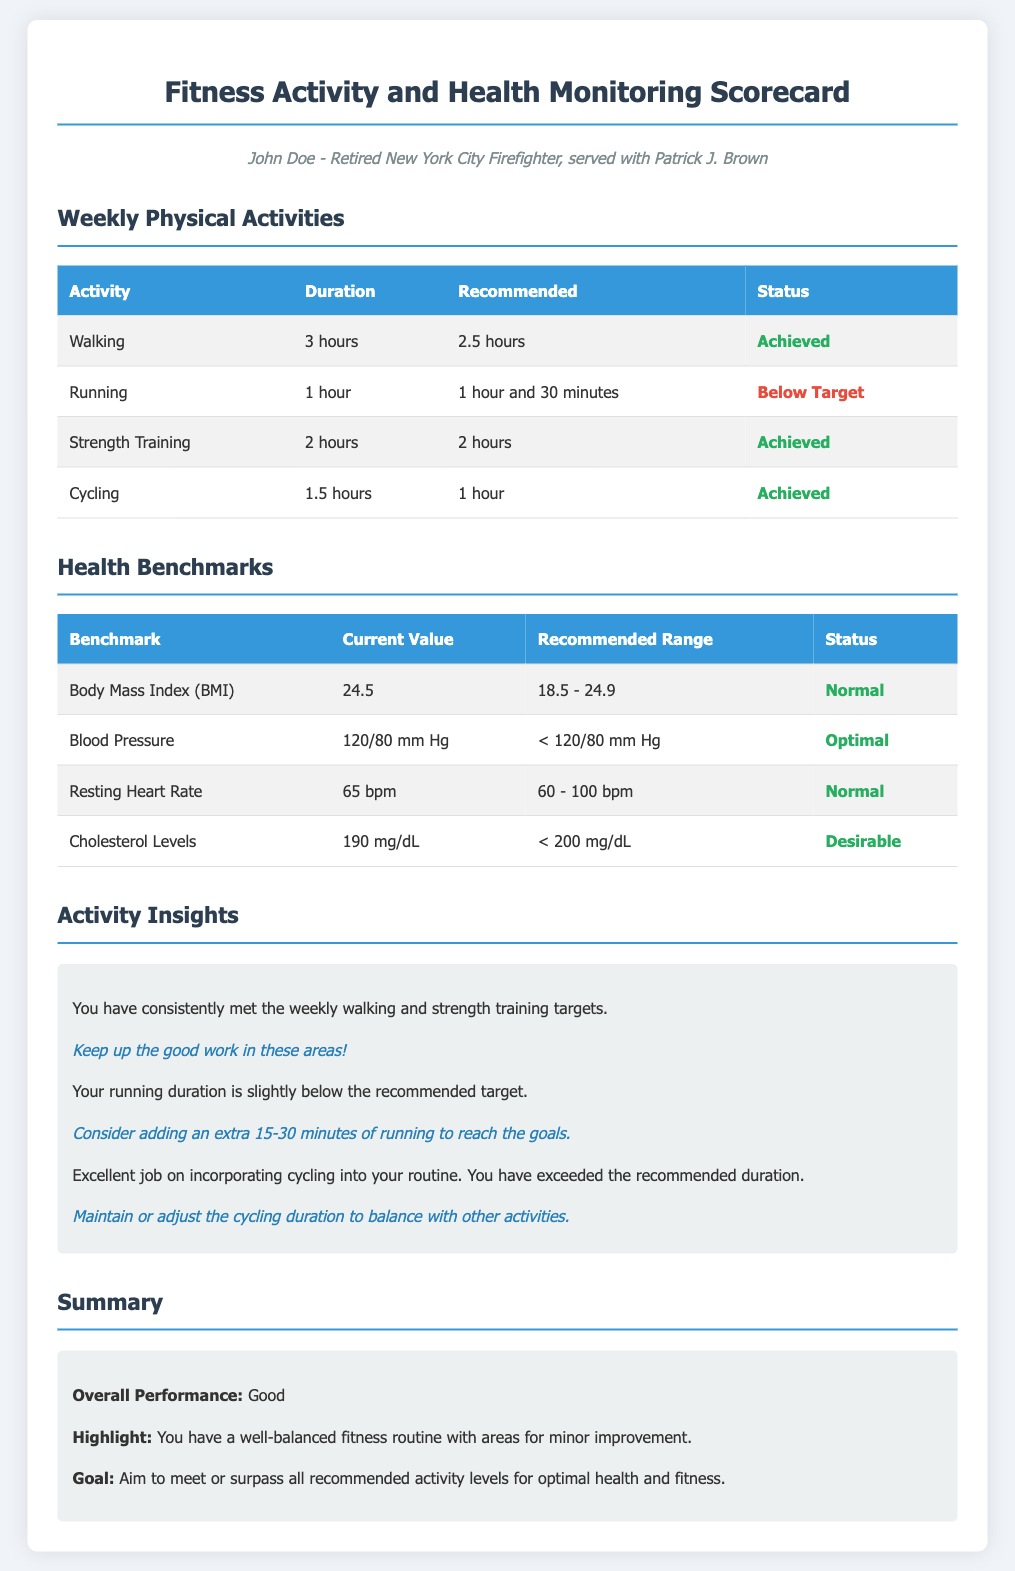What is the total duration of walking? The total duration of walking is specified in the Weekly Physical Activities section of the document as 3 hours.
Answer: 3 hours What is the running target duration? The recommended duration for running is indicated in the Weekly Physical Activities section as 1 hour and 30 minutes.
Answer: 1 hour and 30 minutes What is the Body Mass Index (BMI)? The current value for Body Mass Index is found in the Health Benchmarks section and is stated as 24.5.
Answer: 24.5 What is the status of the Blood Pressure benchmark? The status of Blood Pressure is assessed in the Health Benchmarks section and is categorized as Optimal.
Answer: Optimal Which activity exceeded the recommended duration? The analysis in the Activity Insights section summarizes activities, identifying cycling as exceeding its recommended duration.
Answer: Cycling What does the summary state as the overall performance? The overall performance is provided in the Summary section as Good.
Answer: Good How many hours of Strength Training were recorded? The recorded hours of Strength Training are presented in the Weekly Physical Activities table as 2 hours.
Answer: 2 hours What is the current value of Cholesterol Levels? The current value for Cholesterol Levels is reported in the Health Benchmarks section as 190 mg/dL.
Answer: 190 mg/dL What action is suggested for improving running activity? The suggestion for improving running activity is found in the Activity Insights section, recommending to add an extra 15-30 minutes.
Answer: Add an extra 15-30 minutes 